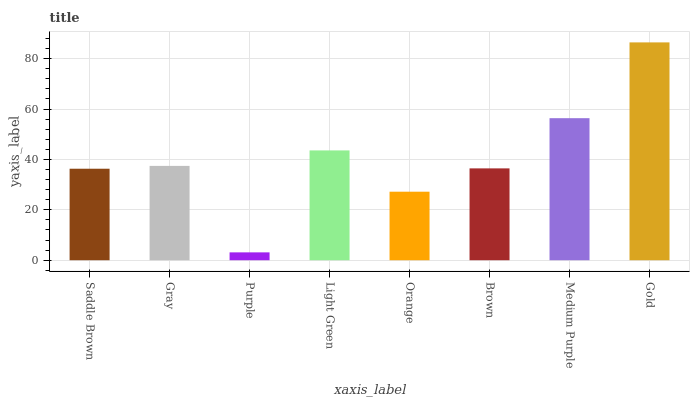Is Purple the minimum?
Answer yes or no. Yes. Is Gold the maximum?
Answer yes or no. Yes. Is Gray the minimum?
Answer yes or no. No. Is Gray the maximum?
Answer yes or no. No. Is Gray greater than Saddle Brown?
Answer yes or no. Yes. Is Saddle Brown less than Gray?
Answer yes or no. Yes. Is Saddle Brown greater than Gray?
Answer yes or no. No. Is Gray less than Saddle Brown?
Answer yes or no. No. Is Gray the high median?
Answer yes or no. Yes. Is Brown the low median?
Answer yes or no. Yes. Is Brown the high median?
Answer yes or no. No. Is Gold the low median?
Answer yes or no. No. 